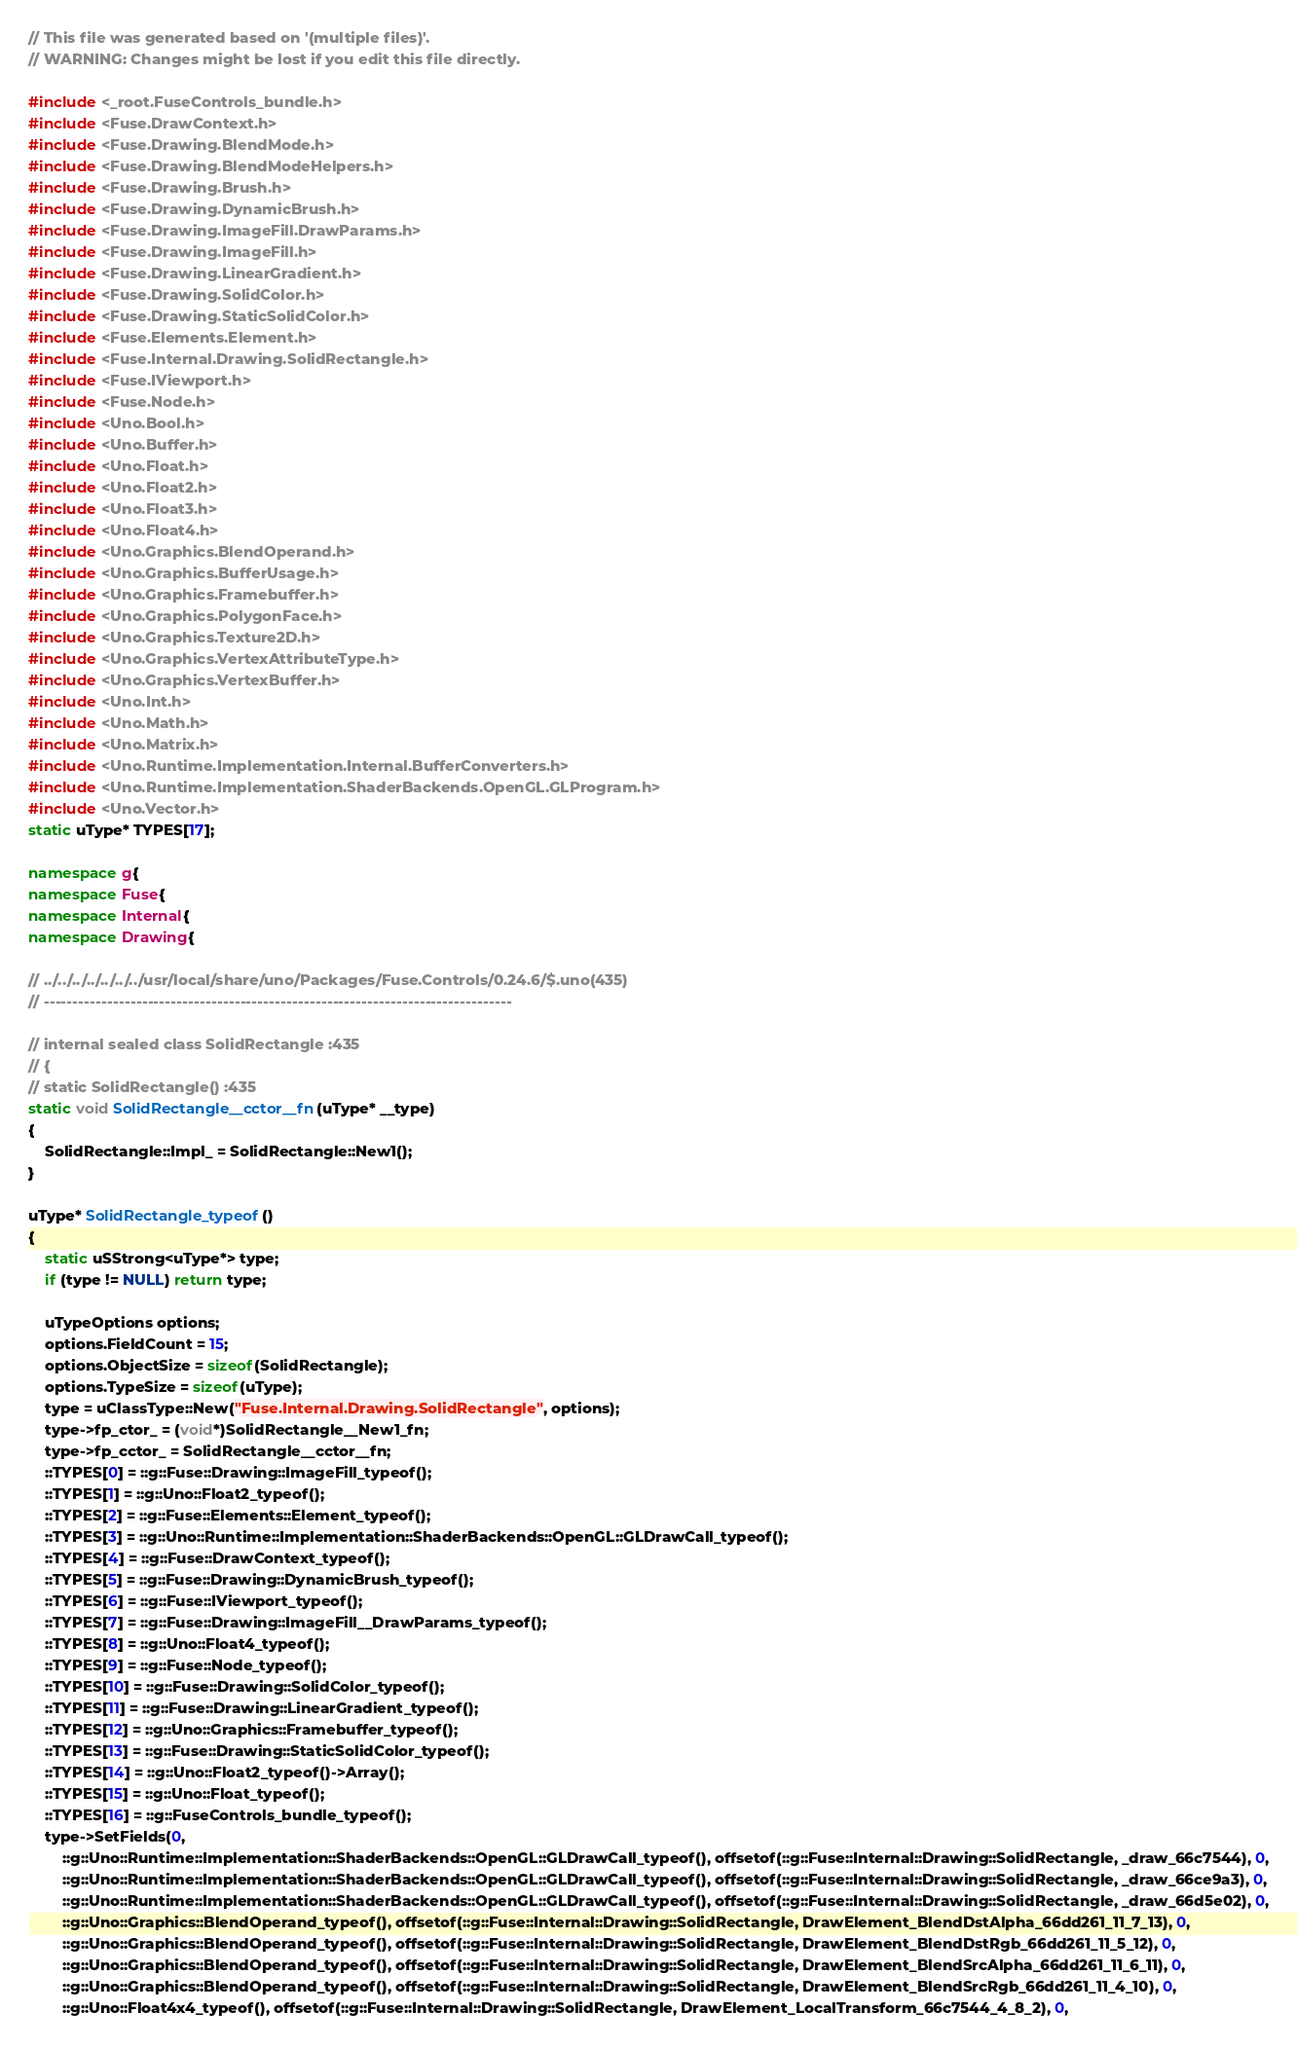<code> <loc_0><loc_0><loc_500><loc_500><_C++_>// This file was generated based on '(multiple files)'.
// WARNING: Changes might be lost if you edit this file directly.

#include <_root.FuseControls_bundle.h>
#include <Fuse.DrawContext.h>
#include <Fuse.Drawing.BlendMode.h>
#include <Fuse.Drawing.BlendModeHelpers.h>
#include <Fuse.Drawing.Brush.h>
#include <Fuse.Drawing.DynamicBrush.h>
#include <Fuse.Drawing.ImageFill.DrawParams.h>
#include <Fuse.Drawing.ImageFill.h>
#include <Fuse.Drawing.LinearGradient.h>
#include <Fuse.Drawing.SolidColor.h>
#include <Fuse.Drawing.StaticSolidColor.h>
#include <Fuse.Elements.Element.h>
#include <Fuse.Internal.Drawing.SolidRectangle.h>
#include <Fuse.IViewport.h>
#include <Fuse.Node.h>
#include <Uno.Bool.h>
#include <Uno.Buffer.h>
#include <Uno.Float.h>
#include <Uno.Float2.h>
#include <Uno.Float3.h>
#include <Uno.Float4.h>
#include <Uno.Graphics.BlendOperand.h>
#include <Uno.Graphics.BufferUsage.h>
#include <Uno.Graphics.Framebuffer.h>
#include <Uno.Graphics.PolygonFace.h>
#include <Uno.Graphics.Texture2D.h>
#include <Uno.Graphics.VertexAttributeType.h>
#include <Uno.Graphics.VertexBuffer.h>
#include <Uno.Int.h>
#include <Uno.Math.h>
#include <Uno.Matrix.h>
#include <Uno.Runtime.Implementation.Internal.BufferConverters.h>
#include <Uno.Runtime.Implementation.ShaderBackends.OpenGL.GLProgram.h>
#include <Uno.Vector.h>
static uType* TYPES[17];

namespace g{
namespace Fuse{
namespace Internal{
namespace Drawing{

// ../../../../../../../usr/local/share/uno/Packages/Fuse.Controls/0.24.6/$.uno(435)
// ---------------------------------------------------------------------------------

// internal sealed class SolidRectangle :435
// {
// static SolidRectangle() :435
static void SolidRectangle__cctor__fn(uType* __type)
{
    SolidRectangle::Impl_ = SolidRectangle::New1();
}

uType* SolidRectangle_typeof()
{
    static uSStrong<uType*> type;
    if (type != NULL) return type;

    uTypeOptions options;
    options.FieldCount = 15;
    options.ObjectSize = sizeof(SolidRectangle);
    options.TypeSize = sizeof(uType);
    type = uClassType::New("Fuse.Internal.Drawing.SolidRectangle", options);
    type->fp_ctor_ = (void*)SolidRectangle__New1_fn;
    type->fp_cctor_ = SolidRectangle__cctor__fn;
    ::TYPES[0] = ::g::Fuse::Drawing::ImageFill_typeof();
    ::TYPES[1] = ::g::Uno::Float2_typeof();
    ::TYPES[2] = ::g::Fuse::Elements::Element_typeof();
    ::TYPES[3] = ::g::Uno::Runtime::Implementation::ShaderBackends::OpenGL::GLDrawCall_typeof();
    ::TYPES[4] = ::g::Fuse::DrawContext_typeof();
    ::TYPES[5] = ::g::Fuse::Drawing::DynamicBrush_typeof();
    ::TYPES[6] = ::g::Fuse::IViewport_typeof();
    ::TYPES[7] = ::g::Fuse::Drawing::ImageFill__DrawParams_typeof();
    ::TYPES[8] = ::g::Uno::Float4_typeof();
    ::TYPES[9] = ::g::Fuse::Node_typeof();
    ::TYPES[10] = ::g::Fuse::Drawing::SolidColor_typeof();
    ::TYPES[11] = ::g::Fuse::Drawing::LinearGradient_typeof();
    ::TYPES[12] = ::g::Uno::Graphics::Framebuffer_typeof();
    ::TYPES[13] = ::g::Fuse::Drawing::StaticSolidColor_typeof();
    ::TYPES[14] = ::g::Uno::Float2_typeof()->Array();
    ::TYPES[15] = ::g::Uno::Float_typeof();
    ::TYPES[16] = ::g::FuseControls_bundle_typeof();
    type->SetFields(0,
        ::g::Uno::Runtime::Implementation::ShaderBackends::OpenGL::GLDrawCall_typeof(), offsetof(::g::Fuse::Internal::Drawing::SolidRectangle, _draw_66c7544), 0,
        ::g::Uno::Runtime::Implementation::ShaderBackends::OpenGL::GLDrawCall_typeof(), offsetof(::g::Fuse::Internal::Drawing::SolidRectangle, _draw_66ce9a3), 0,
        ::g::Uno::Runtime::Implementation::ShaderBackends::OpenGL::GLDrawCall_typeof(), offsetof(::g::Fuse::Internal::Drawing::SolidRectangle, _draw_66d5e02), 0,
        ::g::Uno::Graphics::BlendOperand_typeof(), offsetof(::g::Fuse::Internal::Drawing::SolidRectangle, DrawElement_BlendDstAlpha_66dd261_11_7_13), 0,
        ::g::Uno::Graphics::BlendOperand_typeof(), offsetof(::g::Fuse::Internal::Drawing::SolidRectangle, DrawElement_BlendDstRgb_66dd261_11_5_12), 0,
        ::g::Uno::Graphics::BlendOperand_typeof(), offsetof(::g::Fuse::Internal::Drawing::SolidRectangle, DrawElement_BlendSrcAlpha_66dd261_11_6_11), 0,
        ::g::Uno::Graphics::BlendOperand_typeof(), offsetof(::g::Fuse::Internal::Drawing::SolidRectangle, DrawElement_BlendSrcRgb_66dd261_11_4_10), 0,
        ::g::Uno::Float4x4_typeof(), offsetof(::g::Fuse::Internal::Drawing::SolidRectangle, DrawElement_LocalTransform_66c7544_4_8_2), 0,</code> 